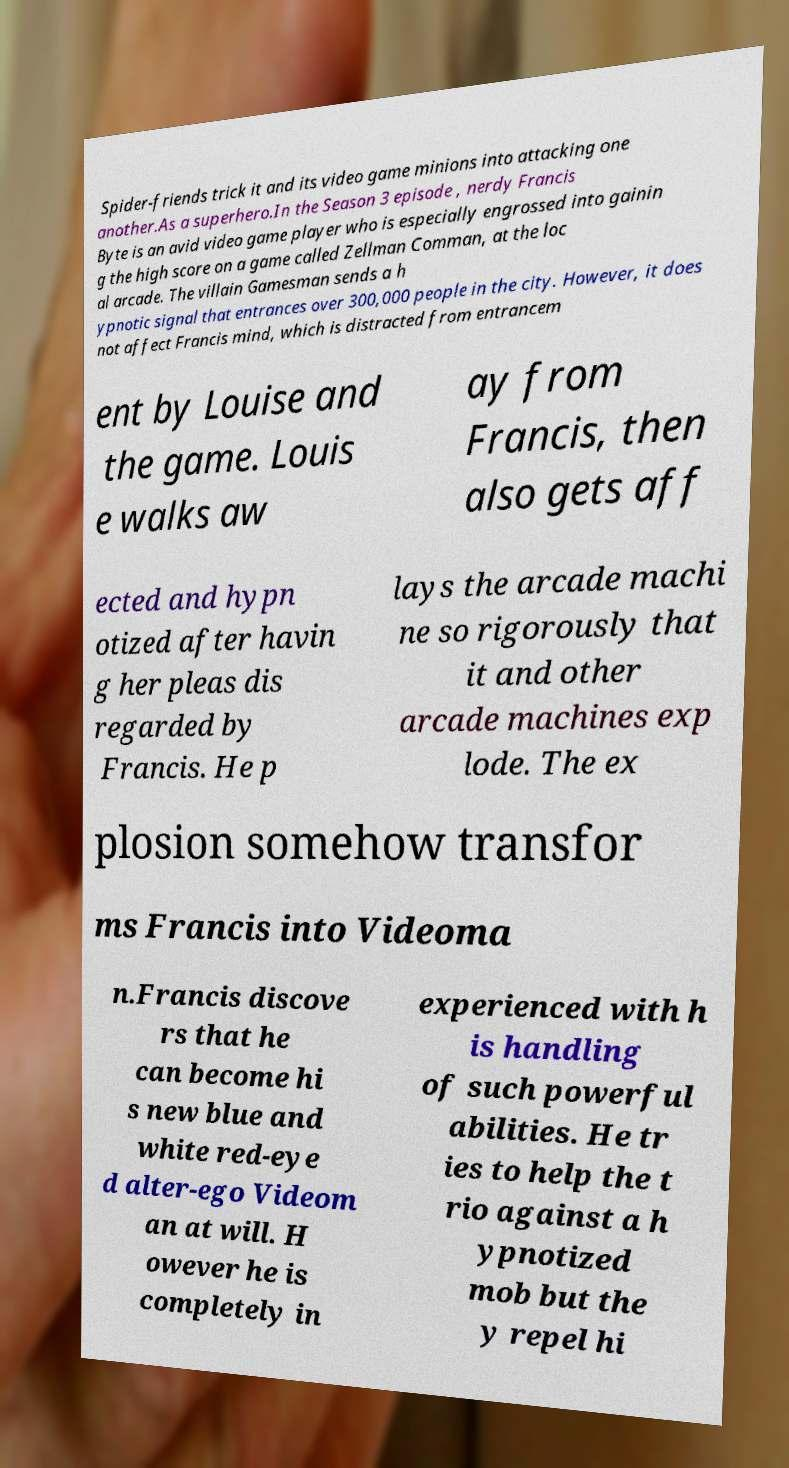Please identify and transcribe the text found in this image. Spider-friends trick it and its video game minions into attacking one another.As a superhero.In the Season 3 episode , nerdy Francis Byte is an avid video game player who is especially engrossed into gainin g the high score on a game called Zellman Comman, at the loc al arcade. The villain Gamesman sends a h ypnotic signal that entrances over 300,000 people in the city. However, it does not affect Francis mind, which is distracted from entrancem ent by Louise and the game. Louis e walks aw ay from Francis, then also gets aff ected and hypn otized after havin g her pleas dis regarded by Francis. He p lays the arcade machi ne so rigorously that it and other arcade machines exp lode. The ex plosion somehow transfor ms Francis into Videoma n.Francis discove rs that he can become hi s new blue and white red-eye d alter-ego Videom an at will. H owever he is completely in experienced with h is handling of such powerful abilities. He tr ies to help the t rio against a h ypnotized mob but the y repel hi 